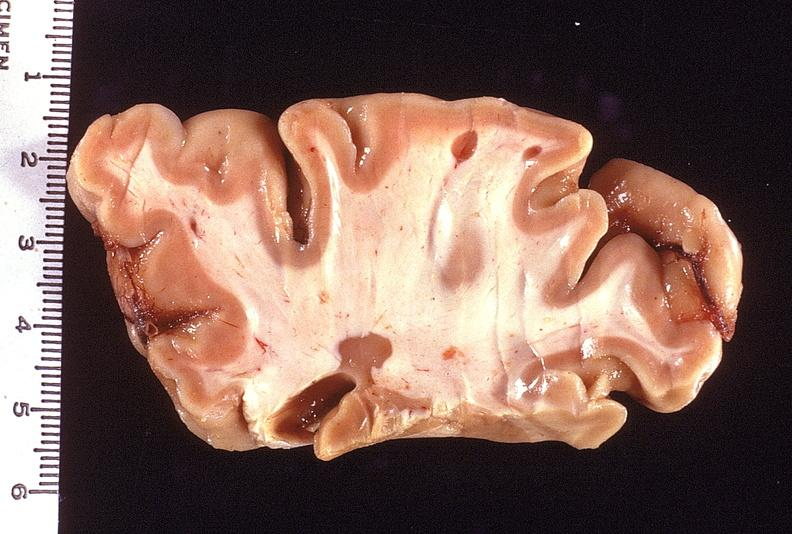does this image show brain, multiple sclerosis?
Answer the question using a single word or phrase. Yes 